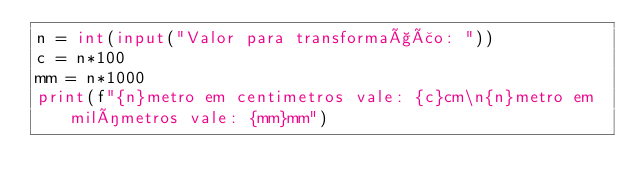Convert code to text. <code><loc_0><loc_0><loc_500><loc_500><_Python_>n = int(input("Valor para transformação: "))
c = n*100
mm = n*1000
print(f"{n}metro em centimetros vale: {c}cm\n{n}metro em milímetros vale: {mm}mm")
</code> 